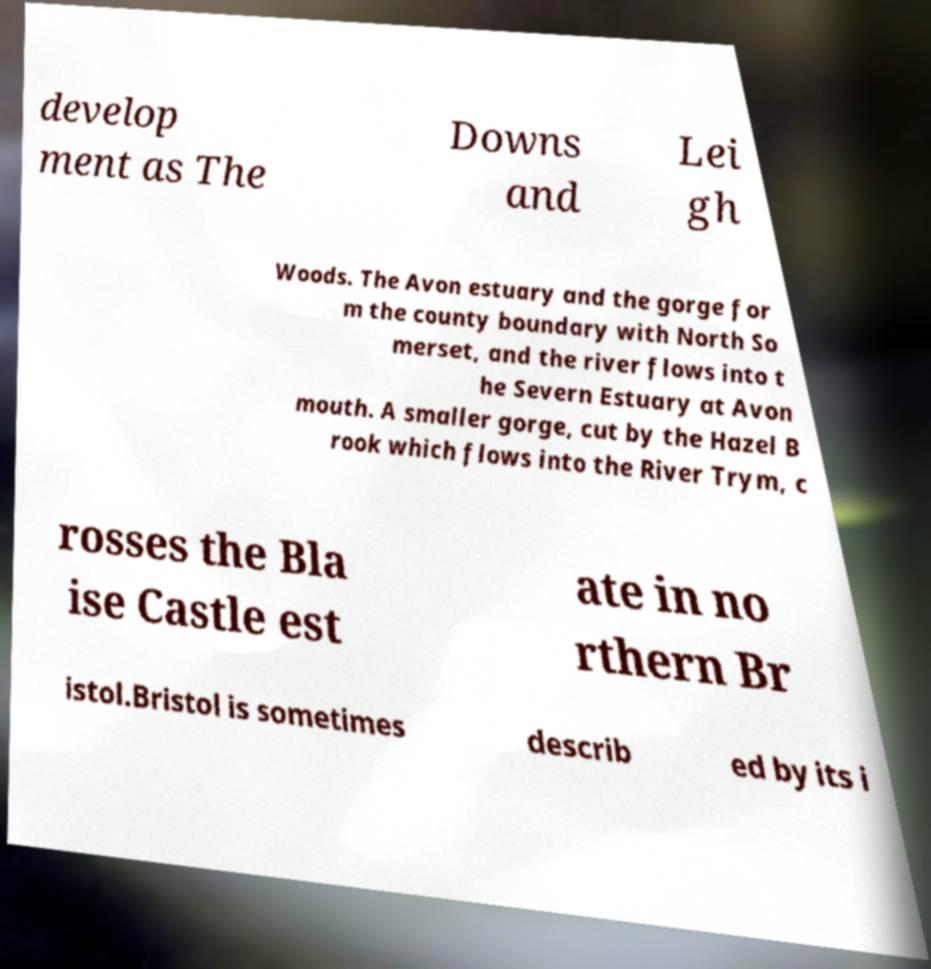Please read and relay the text visible in this image. What does it say? develop ment as The Downs and Lei gh Woods. The Avon estuary and the gorge for m the county boundary with North So merset, and the river flows into t he Severn Estuary at Avon mouth. A smaller gorge, cut by the Hazel B rook which flows into the River Trym, c rosses the Bla ise Castle est ate in no rthern Br istol.Bristol is sometimes describ ed by its i 